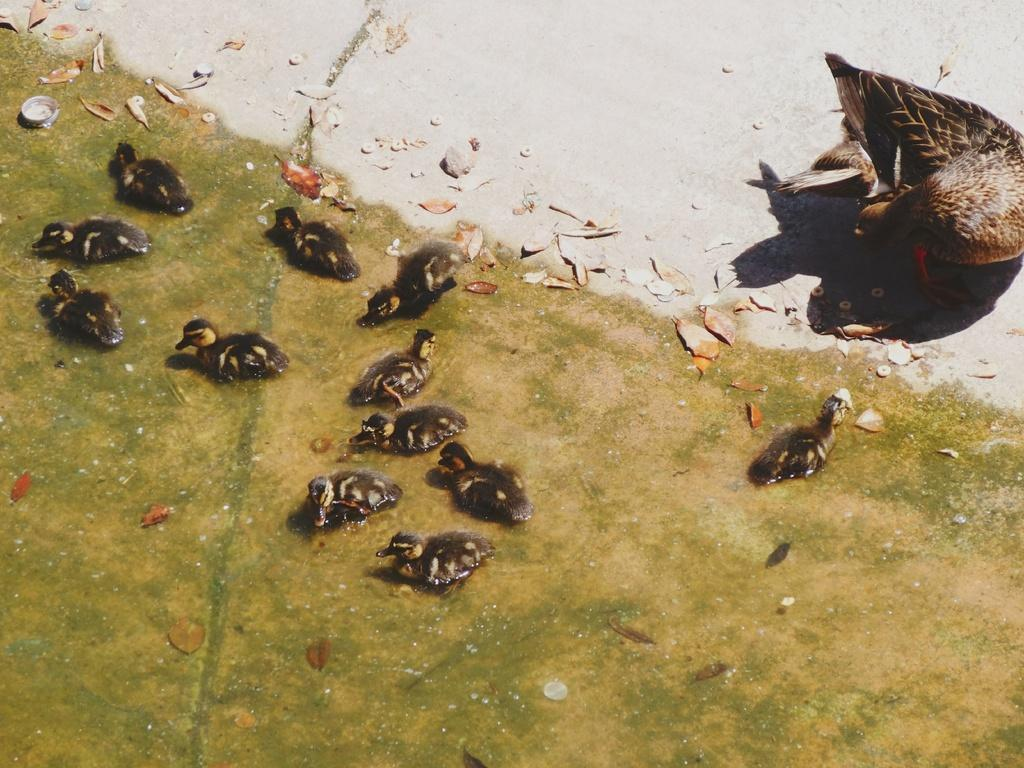What type of animals are in the water in the image? There is a group of ducklings in the water in the image. Can you describe the location of the duck on the ground? The duck is on the ground in the right side of the image. What type of boundary can be seen in the image? There is no boundary present in the image; it features a group of ducklings in the water and a duck on the ground. What season is depicted in the image? The image does not depict a specific season, as there are no seasonal cues present. 